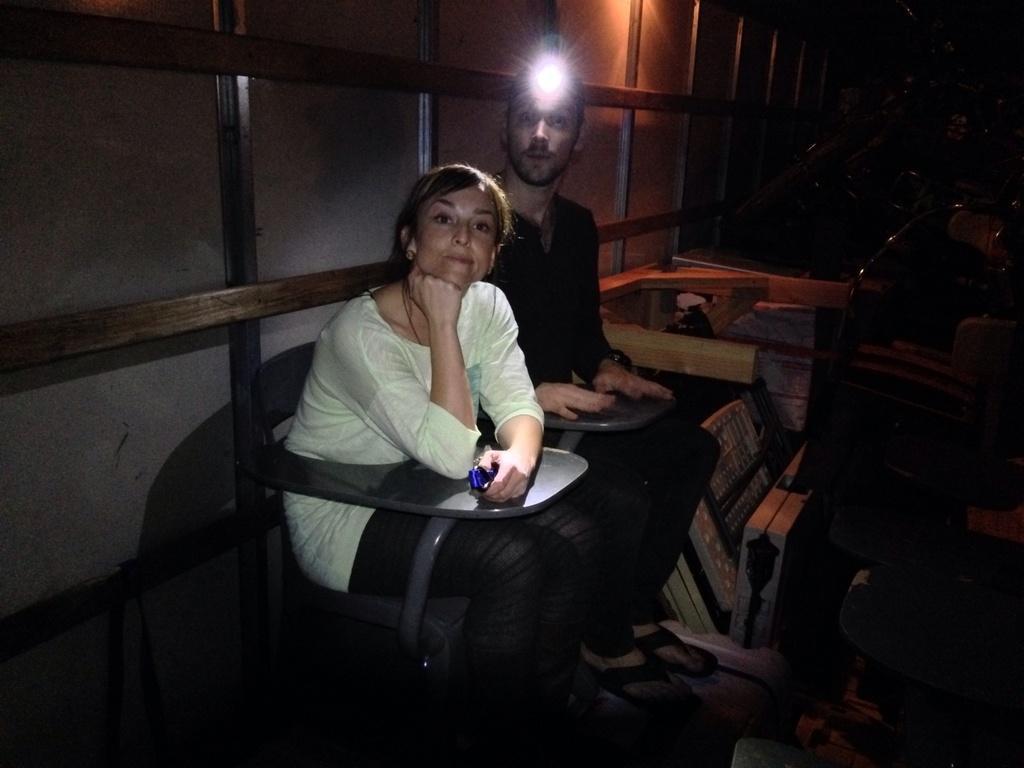In one or two sentences, can you explain what this image depicts? In this image I can see two people are sitting on chairs. I can see one of them is wearing black dress and one is wearing white. I can also see a light over here and I can see this image is little bit in dark from background. 